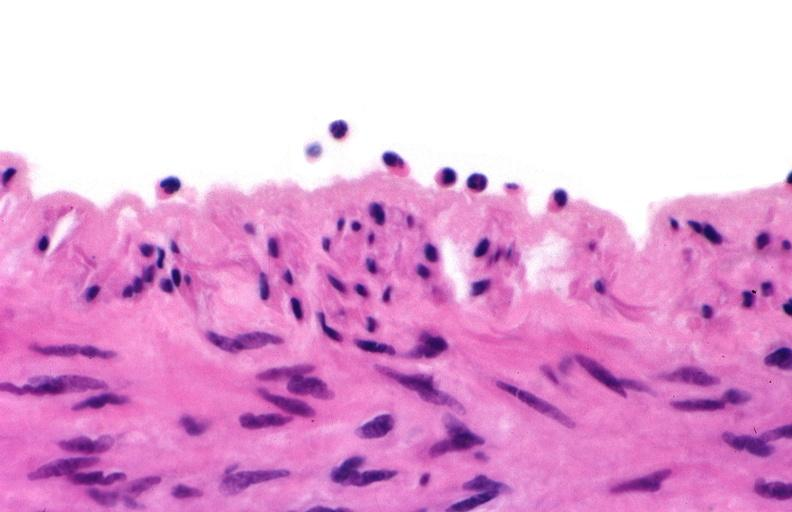does pus in test tube show acute inflammation, rolling leukocytes polymorphonuclear neutrophils?
Answer the question using a single word or phrase. No 